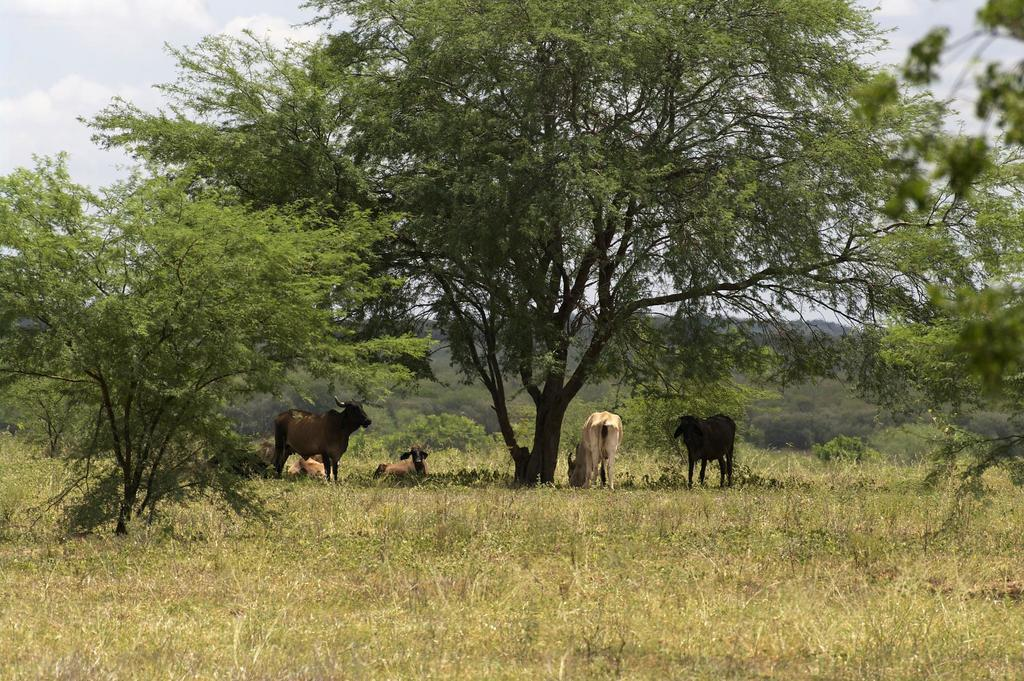What type of animals can be seen on the ground in the image? There are animals on the ground in the image, but their specific type is not mentioned in the facts. What can be seen in the distance behind the animals? There are trees and hills visible in the background of the image. What is present in the sky in the image? There are clouds at the top of the image. What type of disease is affecting the animals in the image? There is no mention of any disease affecting the animals in the image. How much money is visible in the image? There is no mention of money in the image. 